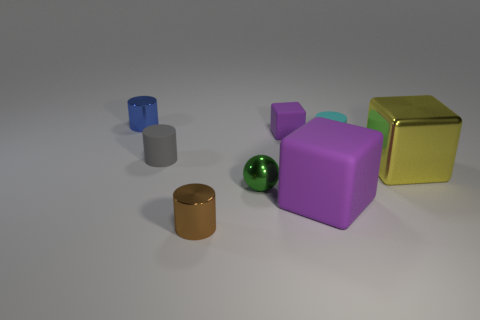There is another rubber object that is the same color as the big matte thing; what size is it?
Keep it short and to the point. Small. Does the yellow object have the same shape as the gray rubber object that is left of the tiny cyan cylinder?
Your answer should be very brief. No. Does the large metallic thing have the same color as the sphere?
Your answer should be very brief. No. Does the gray cylinder have the same size as the blue cylinder?
Your answer should be compact. Yes. Does the large matte thing that is on the right side of the small gray matte cylinder have the same color as the small matte block?
Provide a succinct answer. Yes. There is a big shiny block; how many small purple rubber objects are to the left of it?
Your answer should be very brief. 1. Is the number of metal blocks greater than the number of green cylinders?
Offer a very short reply. Yes. There is a small thing that is behind the cyan thing and on the left side of the tiny purple matte object; what is its shape?
Your answer should be compact. Cylinder. Is there a big metallic block?
Provide a succinct answer. Yes. There is a cyan object that is the same shape as the gray matte object; what is its material?
Make the answer very short. Rubber. 